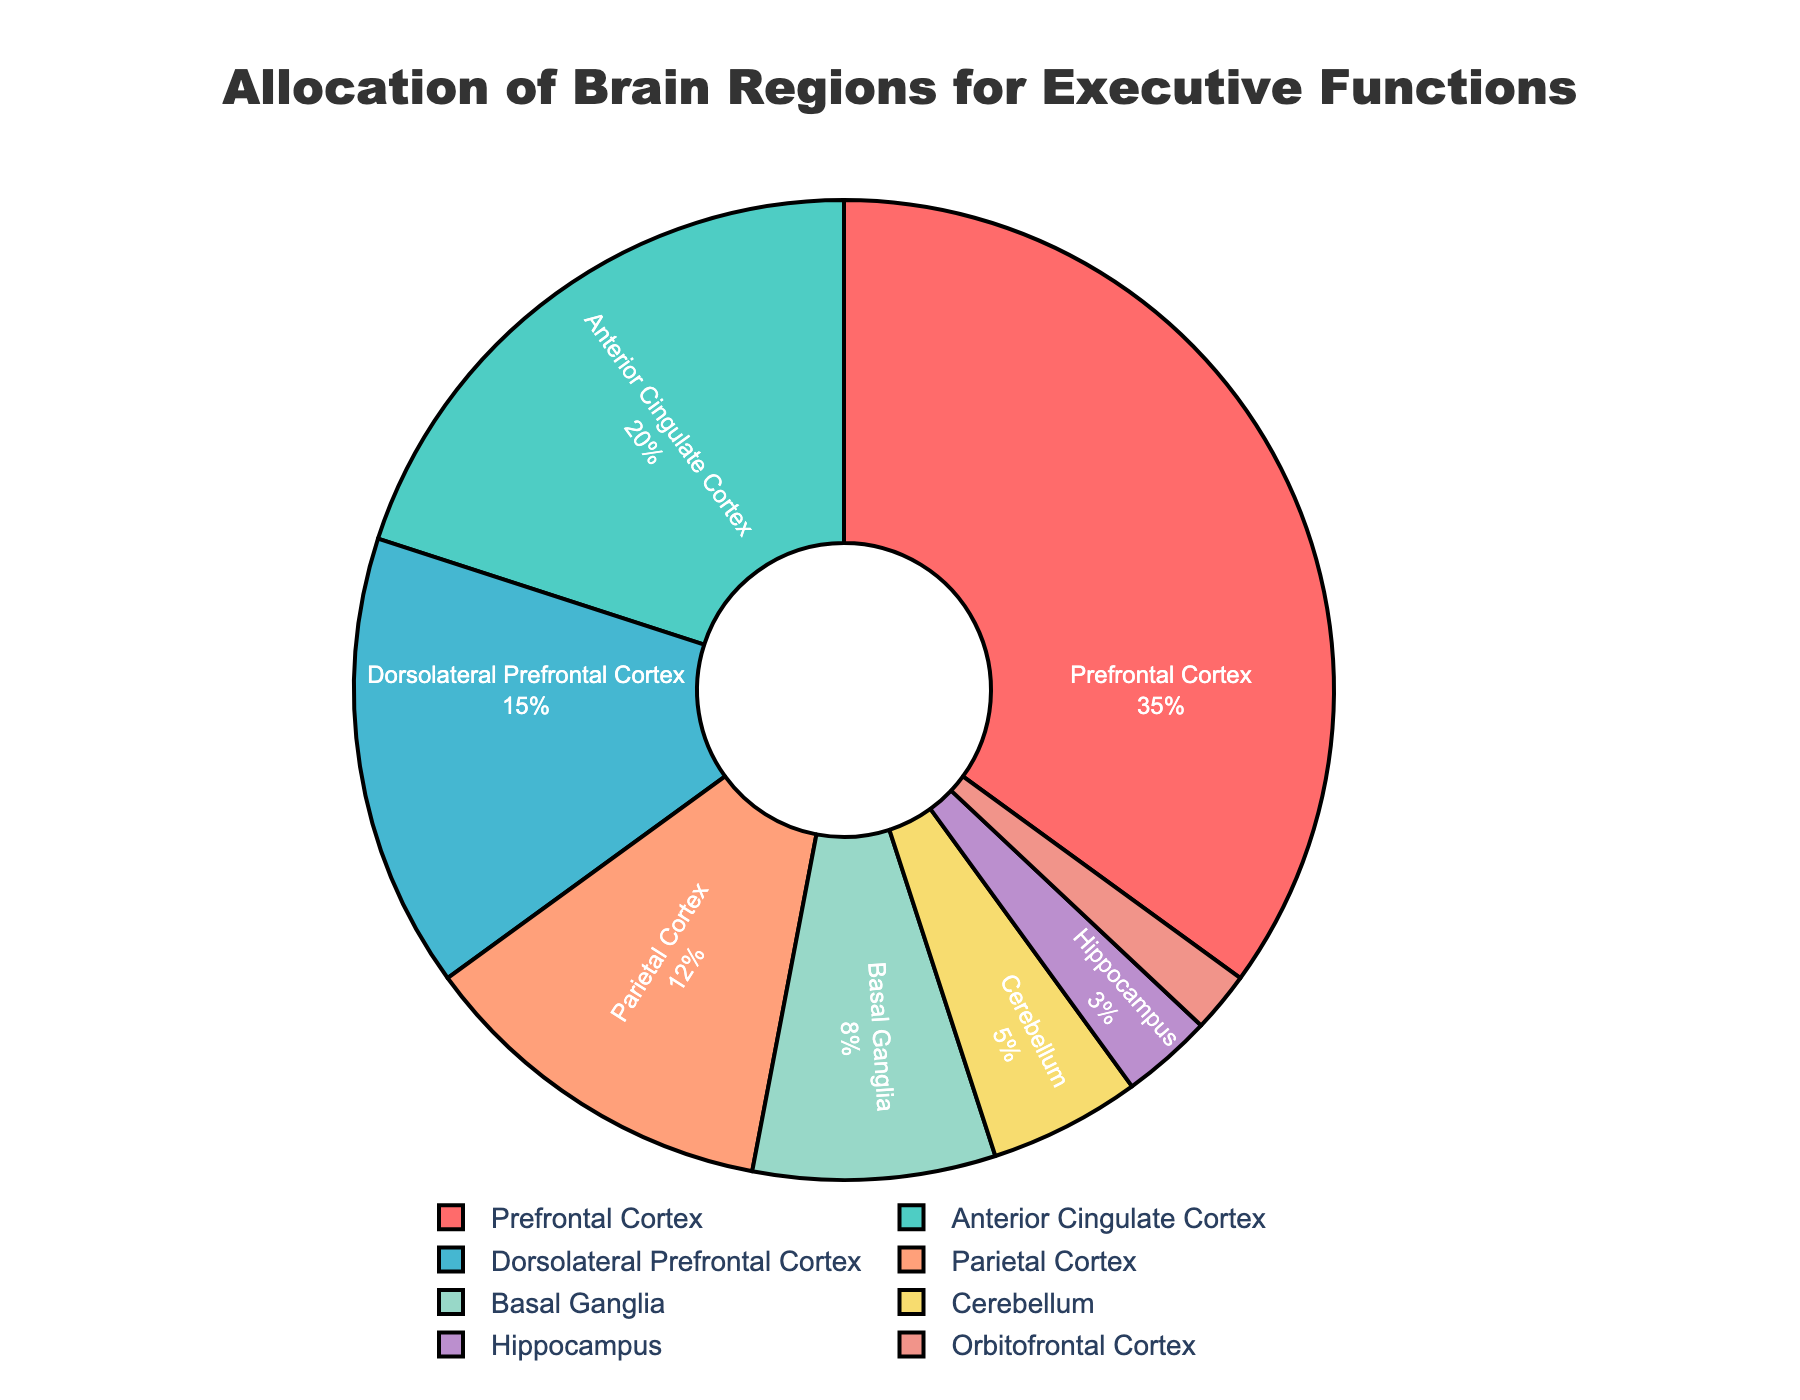Which brain region is responsible for the highest percentage of executive functions? The pie chart shows that the Prefrontal Cortex has the largest slice, indicating it has the highest percentage.
Answer: Prefrontal Cortex Which two brain regions together make up more than 50% of the allocation for executive functions? Adding the percentages from the pie chart: the Prefrontal Cortex (35%) and the Anterior Cingulate Cortex (20%) together have a total of 55%, which is more than 50%.
Answer: Prefrontal Cortex and Anterior Cingulate Cortex How does the percentage allocation for the Dorsolateral Prefrontal Cortex compare to that of the Parietal Cortex? The pie chart shows that the Dorsolateral Prefrontal Cortex has 15% and the Parietal Cortex has 12%. Since 15% is greater than 12%, the Dorsolateral Prefrontal Cortex has a higher allocation.
Answer: Dorsolateral Prefrontal Cortex has a higher allocation What is the combined percentage of the Basal Ganglia and Cerebellum? From the pie chart, the Basal Ganglia has 8% and the Cerebellum has 5%. Adding these together gives 8% + 5% = 13%.
Answer: 13% Which brain region has the smallest allocation, and what is its percentage? The smallest slice in the pie chart is the Orbitofrontal Cortex with 2%.
Answer: Orbitofrontal Cortex, 2% How does the allocation percentage for the Hippocampus compare with the sum of the Orbitofrontal Cortex and the Cerebellum? The pie chart shows the Hippocampus with 3%, Orbitofrontal Cortex with 2%, and Cerebellum with 5%. Summing Orbitofrontal Cortex and Cerebellum yields 2% + 5% = 7%. 3% is less than 7%, so the Hippocampus has a smaller allocation.
Answer: Hippocampus is less What percentage more does the Prefrontal Cortex have compared to the Dorsolateral Prefrontal Cortex? The pie chart shows the Prefrontal Cortex at 35% and the Dorsolateral Prefrontal Cortex at 15%. The difference is 35% - 15%, which is 20%.
Answer: 20% Which regions, together, make up less than 10%? From the pie chart, the regions with less than 10% each are the Hippocampus (3%) and the Orbitofrontal Cortex (2%). Combining them gives 3% + 2% = 5%, which is less than 10%.
Answer: Hippocampus and Orbitofrontal Cortex What is the difference in allocation percentage between the Parietal Cortex and the Basal Ganglia? The pie chart shows the Parietal Cortex at 12% and the Basal Ganglia at 8%. The difference is 12% - 8%, which equals 4%.
Answer: 4% How does the color-correlated brain region of Basal Ganglia visually compare with that of the Cerebellum? The pie chart shows Basal Ganglia in a light green color, while the Cerebellum is shown in a light yellow color. The colors clearly differentiate the two regions.
Answer: Basal Ganglia is light green, Cerebellum is light yellow 